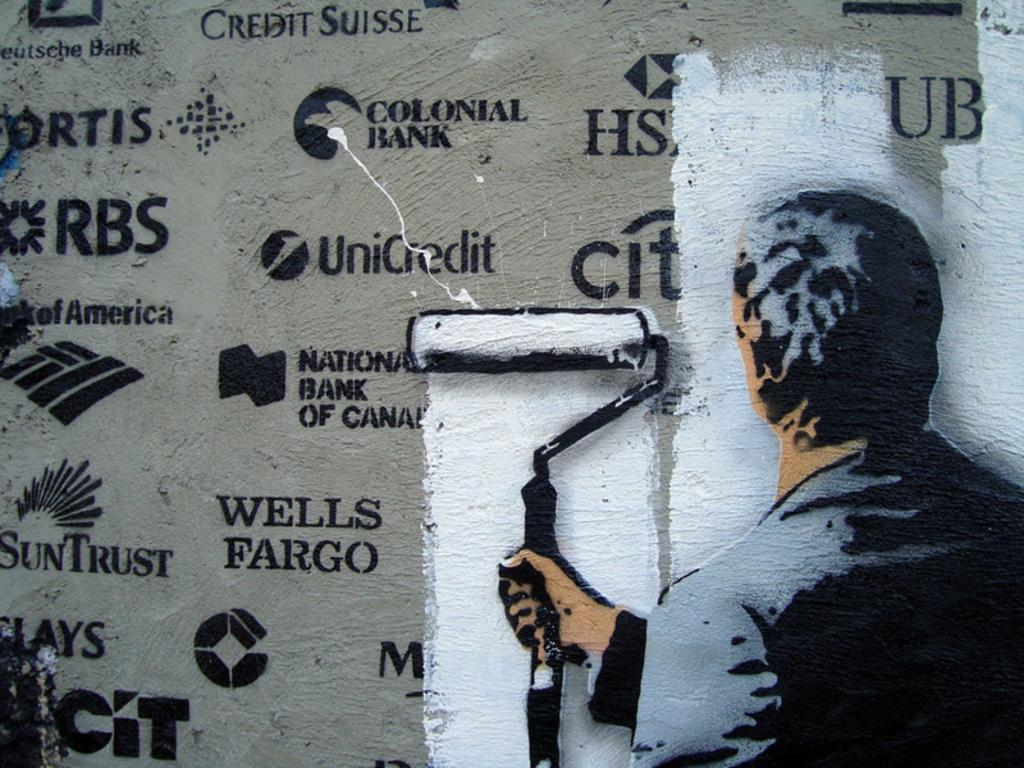<image>
Relay a brief, clear account of the picture shown. Person using white paint to paint over a Citibank logo. 